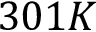Convert formula to latex. <formula><loc_0><loc_0><loc_500><loc_500>3 0 1 K</formula> 